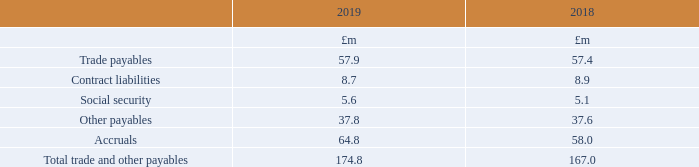19 Trade and other payables
Contract liabilities relate to advance payments received from customers which have not yet been recognised as revenue. £8.3m of the contract liabilities at 31st December 2018 was recognised as revenue during 2019 (2018: £3.0m).
What do contract liabilities relate to? Advance payments received from customers which have not yet been recognised as revenue. How much of contract liabilities at 31st December 2018 was recognised as revenue during 2019? £8.3m. What are the components making up total trade and other payables? Trade payables, contract liabilities, social security, other payables, accruals. In which year was the amount of trade payables larger? 57.9>57.4
Answer: 2019. What was the change in accruals in 2019 from 2018?
Answer scale should be: million. 64.8-58.0
Answer: 6.8. What was the percentage change in accruals in 2019 from 2018?
Answer scale should be: percent. (64.8-58.0)/58.0
Answer: 11.72. 